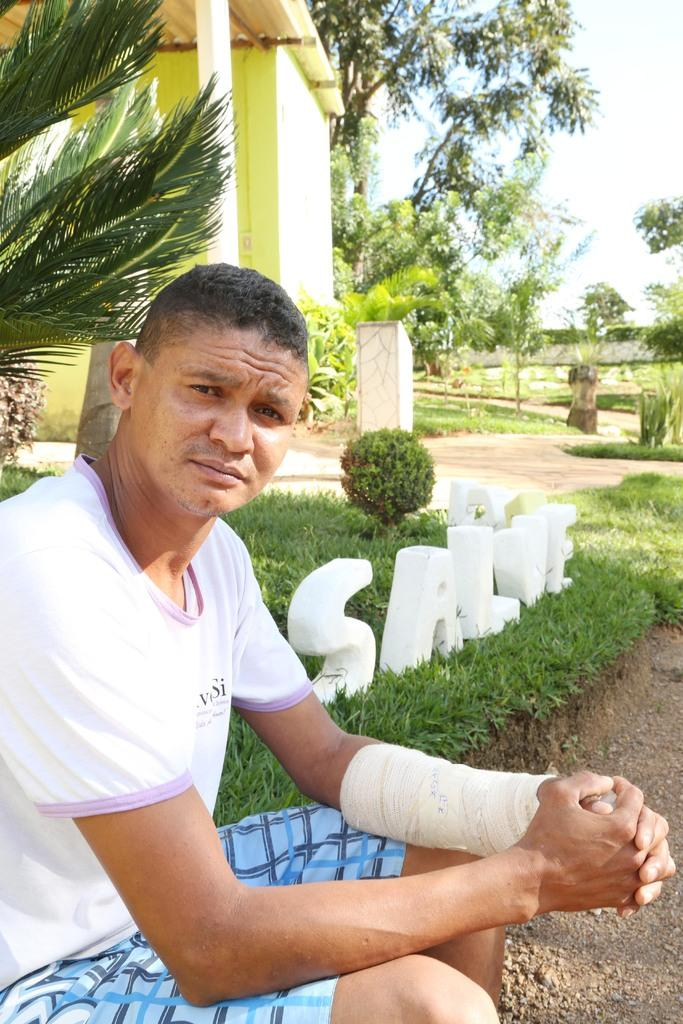What is the condition of the person's hand in the image? The person in the image has a bandage on one hand. What can be seen on the grass in the image? There is a name made of stones on the grass. What type of structures are present in the image? Stone pillars are present in the image. What type of vegetation is visible in the image? Trees and garden plants are present in the image. What type of building is visible in the image? There is a building in the image. What is visible in the sky in the image? The sky is visible in the image. Where is the group of swings located in the image? There are no swings present in the image. What type of metal is used to make the name on the grass? The name on the grass is made of stones, not metal, so it is not possible to determine the type of metal used. 